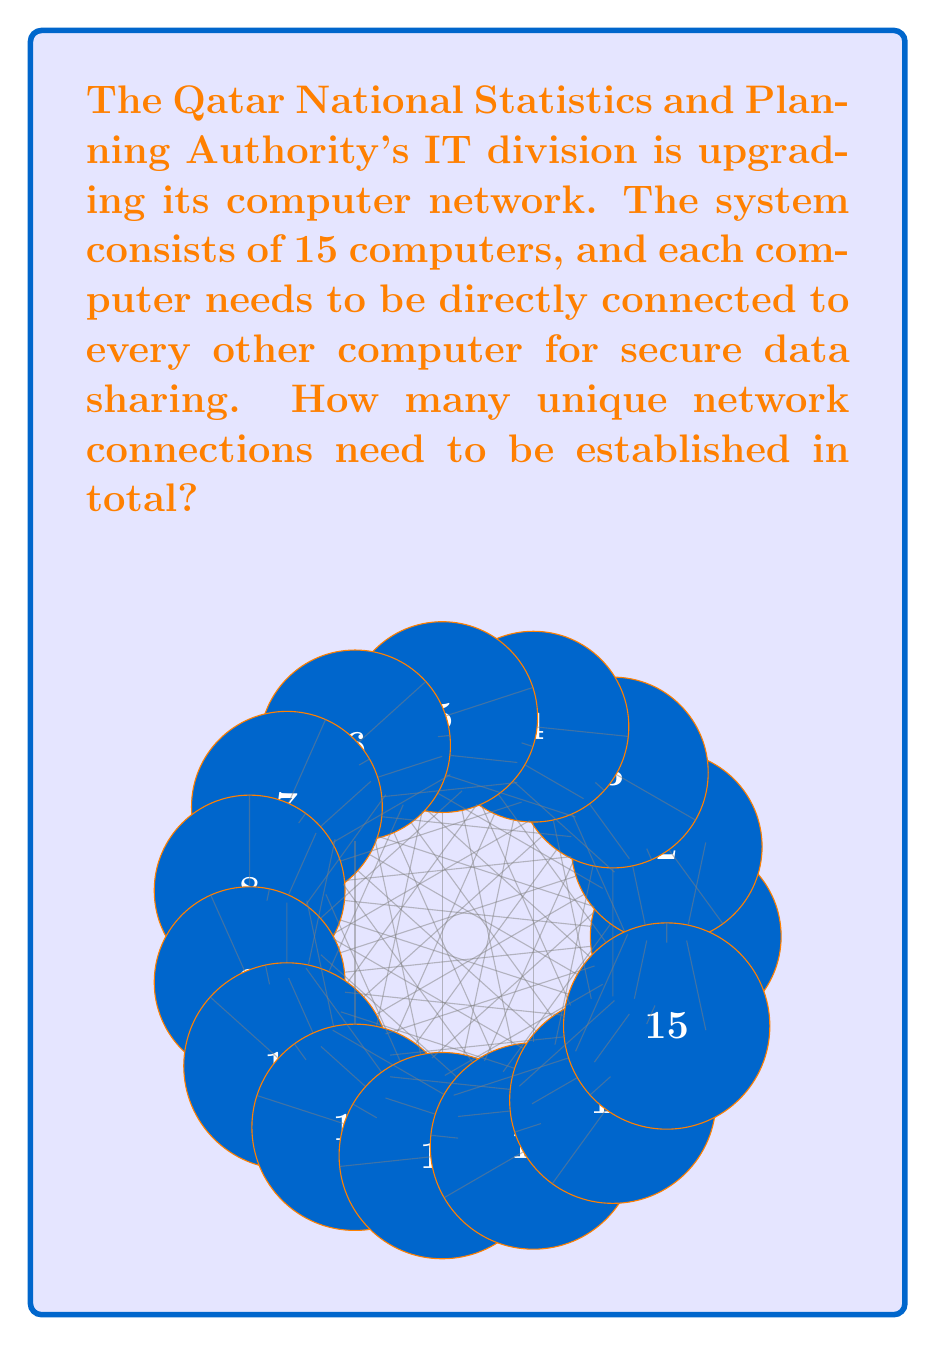Show me your answer to this math problem. To solve this problem, we need to use the concept of combinations. Here's a step-by-step explanation:

1) Each connection links two computers. We need to find the number of ways to choose 2 computers from 15.

2) This is a combination problem, denoted as $C(15,2)$ or $\binom{15}{2}$.

3) The formula for this combination is:

   $$\binom{15}{2} = \frac{15!}{2!(15-2)!} = \frac{15!}{2!(13)!}$$

4) Expanding this:
   $$\frac{15 \times 14 \times 13!}{2 \times 1 \times 13!}$$

5) The 13! cancels out in the numerator and denominator:
   $$\frac{15 \times 14}{2 \times 1} = \frac{210}{2}$$

6) Calculating the final result:
   $$\frac{210}{2} = 105$$

Therefore, 105 unique network connections need to be established.
Answer: 105 connections 